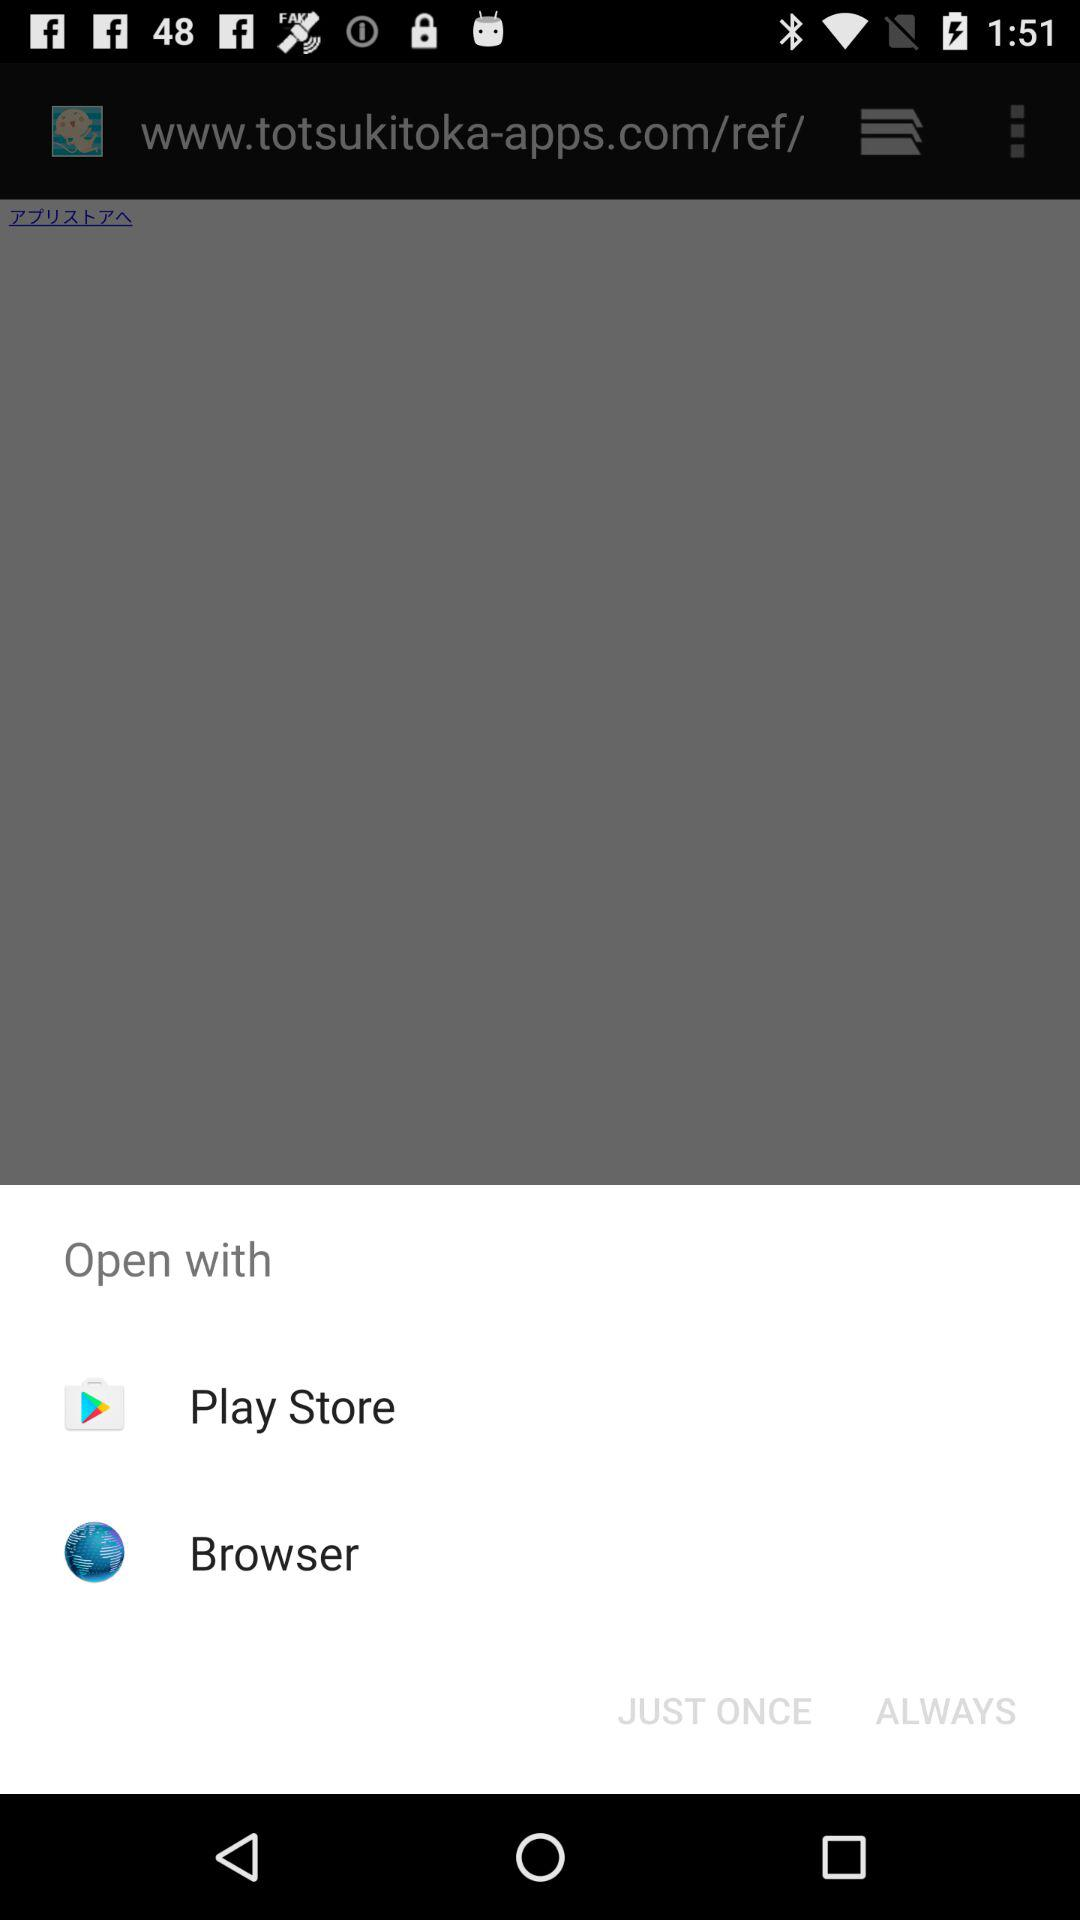How many options are there in the open with menu?
Answer the question using a single word or phrase. 2 